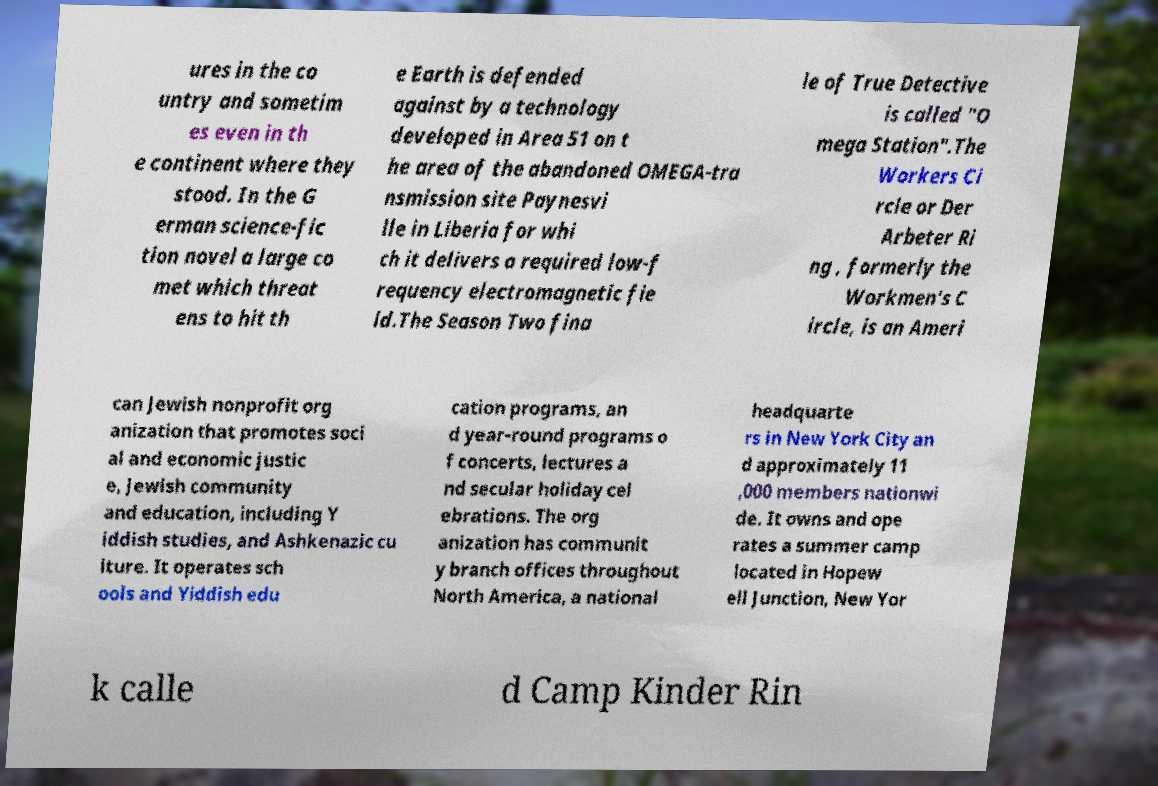Please identify and transcribe the text found in this image. ures in the co untry and sometim es even in th e continent where they stood. In the G erman science-fic tion novel a large co met which threat ens to hit th e Earth is defended against by a technology developed in Area 51 on t he area of the abandoned OMEGA-tra nsmission site Paynesvi lle in Liberia for whi ch it delivers a required low-f requency electromagnetic fie ld.The Season Two fina le of True Detective is called "O mega Station".The Workers Ci rcle or Der Arbeter Ri ng , formerly the Workmen's C ircle, is an Ameri can Jewish nonprofit org anization that promotes soci al and economic justic e, Jewish community and education, including Y iddish studies, and Ashkenazic cu lture. It operates sch ools and Yiddish edu cation programs, an d year-round programs o f concerts, lectures a nd secular holiday cel ebrations. The org anization has communit y branch offices throughout North America, a national headquarte rs in New York City an d approximately 11 ,000 members nationwi de. It owns and ope rates a summer camp located in Hopew ell Junction, New Yor k calle d Camp Kinder Rin 